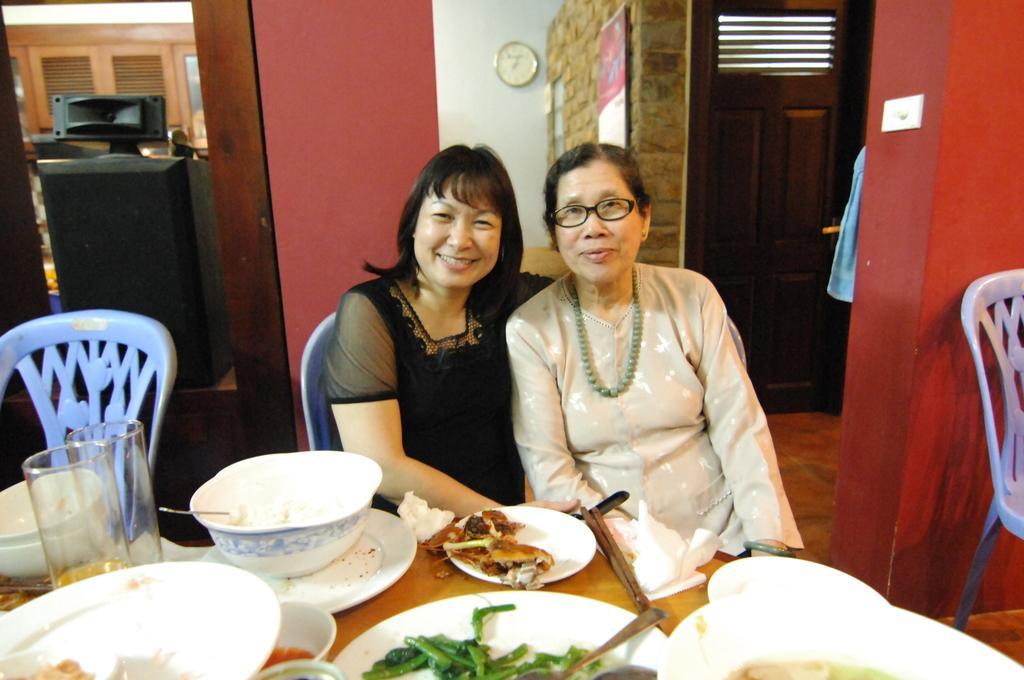Please provide a concise description of this image. In this image I can see two people are sitting on chairs. In-front of them there is a table, on the table there are bowls, plates, food, chopsticks and objects. In the background of the image there are walls, speaker, doors, clock, board and objects. Clock is on the wall.   